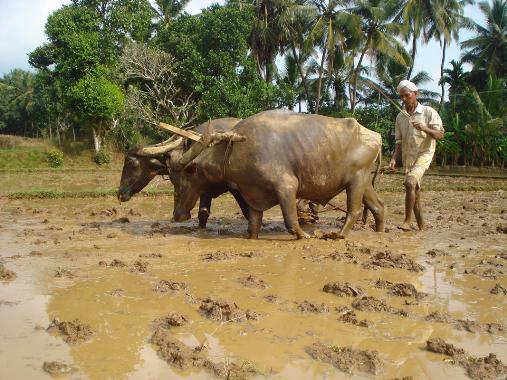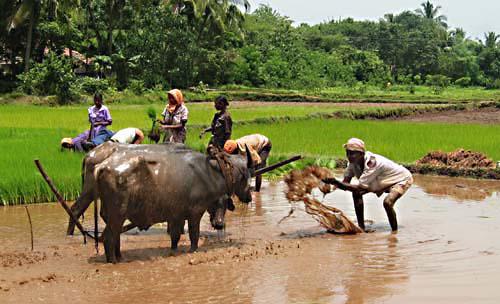The first image is the image on the left, the second image is the image on the right. For the images shown, is this caption "Each image shows at least one man interacting with a team of two hitched oxen, and one image shows a man holding a stick behind oxen." true? Answer yes or no. Yes. The first image is the image on the left, the second image is the image on the right. For the images shown, is this caption "In one of the images, water buffalos are standing in muddy water." true? Answer yes or no. Yes. 